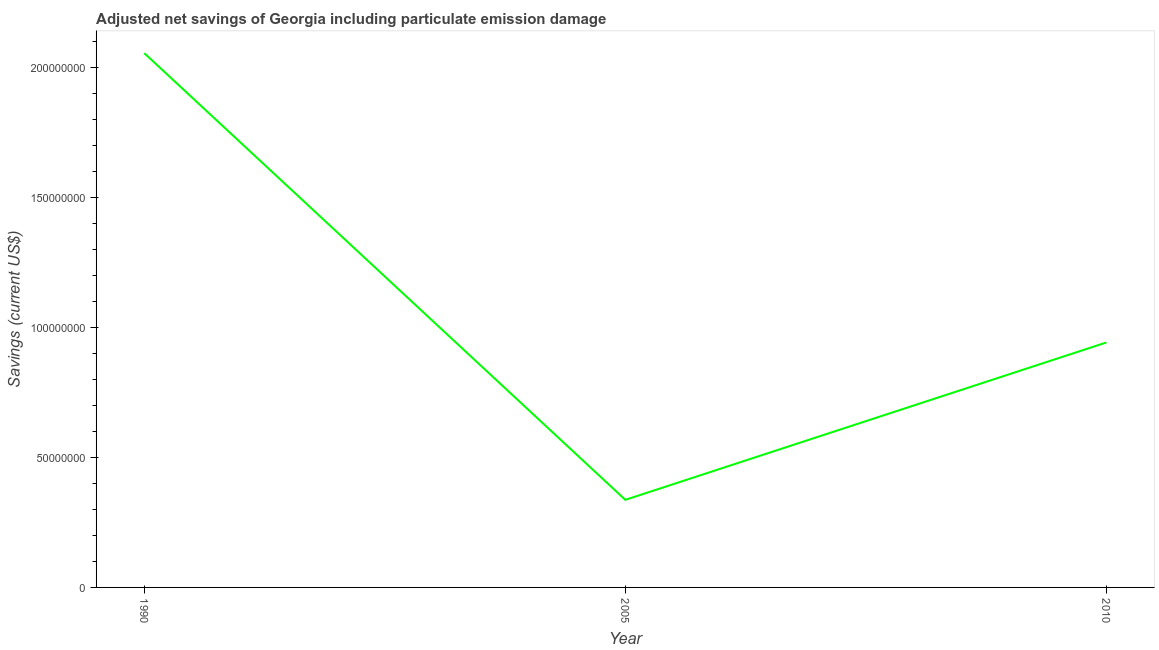What is the adjusted net savings in 2010?
Offer a very short reply. 9.43e+07. Across all years, what is the maximum adjusted net savings?
Ensure brevity in your answer.  2.06e+08. Across all years, what is the minimum adjusted net savings?
Provide a short and direct response. 3.37e+07. What is the sum of the adjusted net savings?
Offer a terse response. 3.34e+08. What is the difference between the adjusted net savings in 1990 and 2005?
Your response must be concise. 1.72e+08. What is the average adjusted net savings per year?
Make the answer very short. 1.11e+08. What is the median adjusted net savings?
Ensure brevity in your answer.  9.43e+07. Do a majority of the years between 2010 and 2005 (inclusive) have adjusted net savings greater than 30000000 US$?
Give a very brief answer. No. What is the ratio of the adjusted net savings in 2005 to that in 2010?
Your response must be concise. 0.36. Is the difference between the adjusted net savings in 1990 and 2005 greater than the difference between any two years?
Offer a terse response. Yes. What is the difference between the highest and the second highest adjusted net savings?
Ensure brevity in your answer.  1.11e+08. What is the difference between the highest and the lowest adjusted net savings?
Your answer should be compact. 1.72e+08. How many lines are there?
Give a very brief answer. 1. What is the title of the graph?
Keep it short and to the point. Adjusted net savings of Georgia including particulate emission damage. What is the label or title of the Y-axis?
Ensure brevity in your answer.  Savings (current US$). What is the Savings (current US$) of 1990?
Provide a short and direct response. 2.06e+08. What is the Savings (current US$) of 2005?
Offer a terse response. 3.37e+07. What is the Savings (current US$) in 2010?
Provide a succinct answer. 9.43e+07. What is the difference between the Savings (current US$) in 1990 and 2005?
Your answer should be compact. 1.72e+08. What is the difference between the Savings (current US$) in 1990 and 2010?
Your answer should be compact. 1.11e+08. What is the difference between the Savings (current US$) in 2005 and 2010?
Provide a succinct answer. -6.06e+07. What is the ratio of the Savings (current US$) in 1990 to that in 2005?
Give a very brief answer. 6.1. What is the ratio of the Savings (current US$) in 1990 to that in 2010?
Ensure brevity in your answer.  2.18. What is the ratio of the Savings (current US$) in 2005 to that in 2010?
Ensure brevity in your answer.  0.36. 